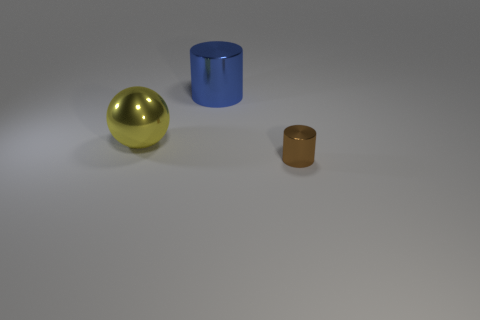What is the material of the brown object that is the same shape as the large blue thing?
Give a very brief answer. Metal. How many blocks are either red objects or big yellow shiny objects?
Provide a short and direct response. 0. There is a metal object that is to the left of the small cylinder and right of the yellow metallic object; what is its color?
Your answer should be very brief. Blue. The object behind the object on the left side of the blue object is what color?
Give a very brief answer. Blue. Is the size of the brown cylinder the same as the yellow metallic thing?
Offer a terse response. No. Is the cylinder that is behind the brown cylinder made of the same material as the big object that is left of the large cylinder?
Your answer should be very brief. Yes. The large object left of the cylinder left of the metallic thing that is in front of the metal sphere is what shape?
Your answer should be very brief. Sphere. Is the number of cylinders greater than the number of blue metallic objects?
Your answer should be very brief. Yes. Are there any large blue balls?
Give a very brief answer. No. How many objects are things that are behind the small brown object or large shiny balls that are left of the small metallic thing?
Make the answer very short. 2. 